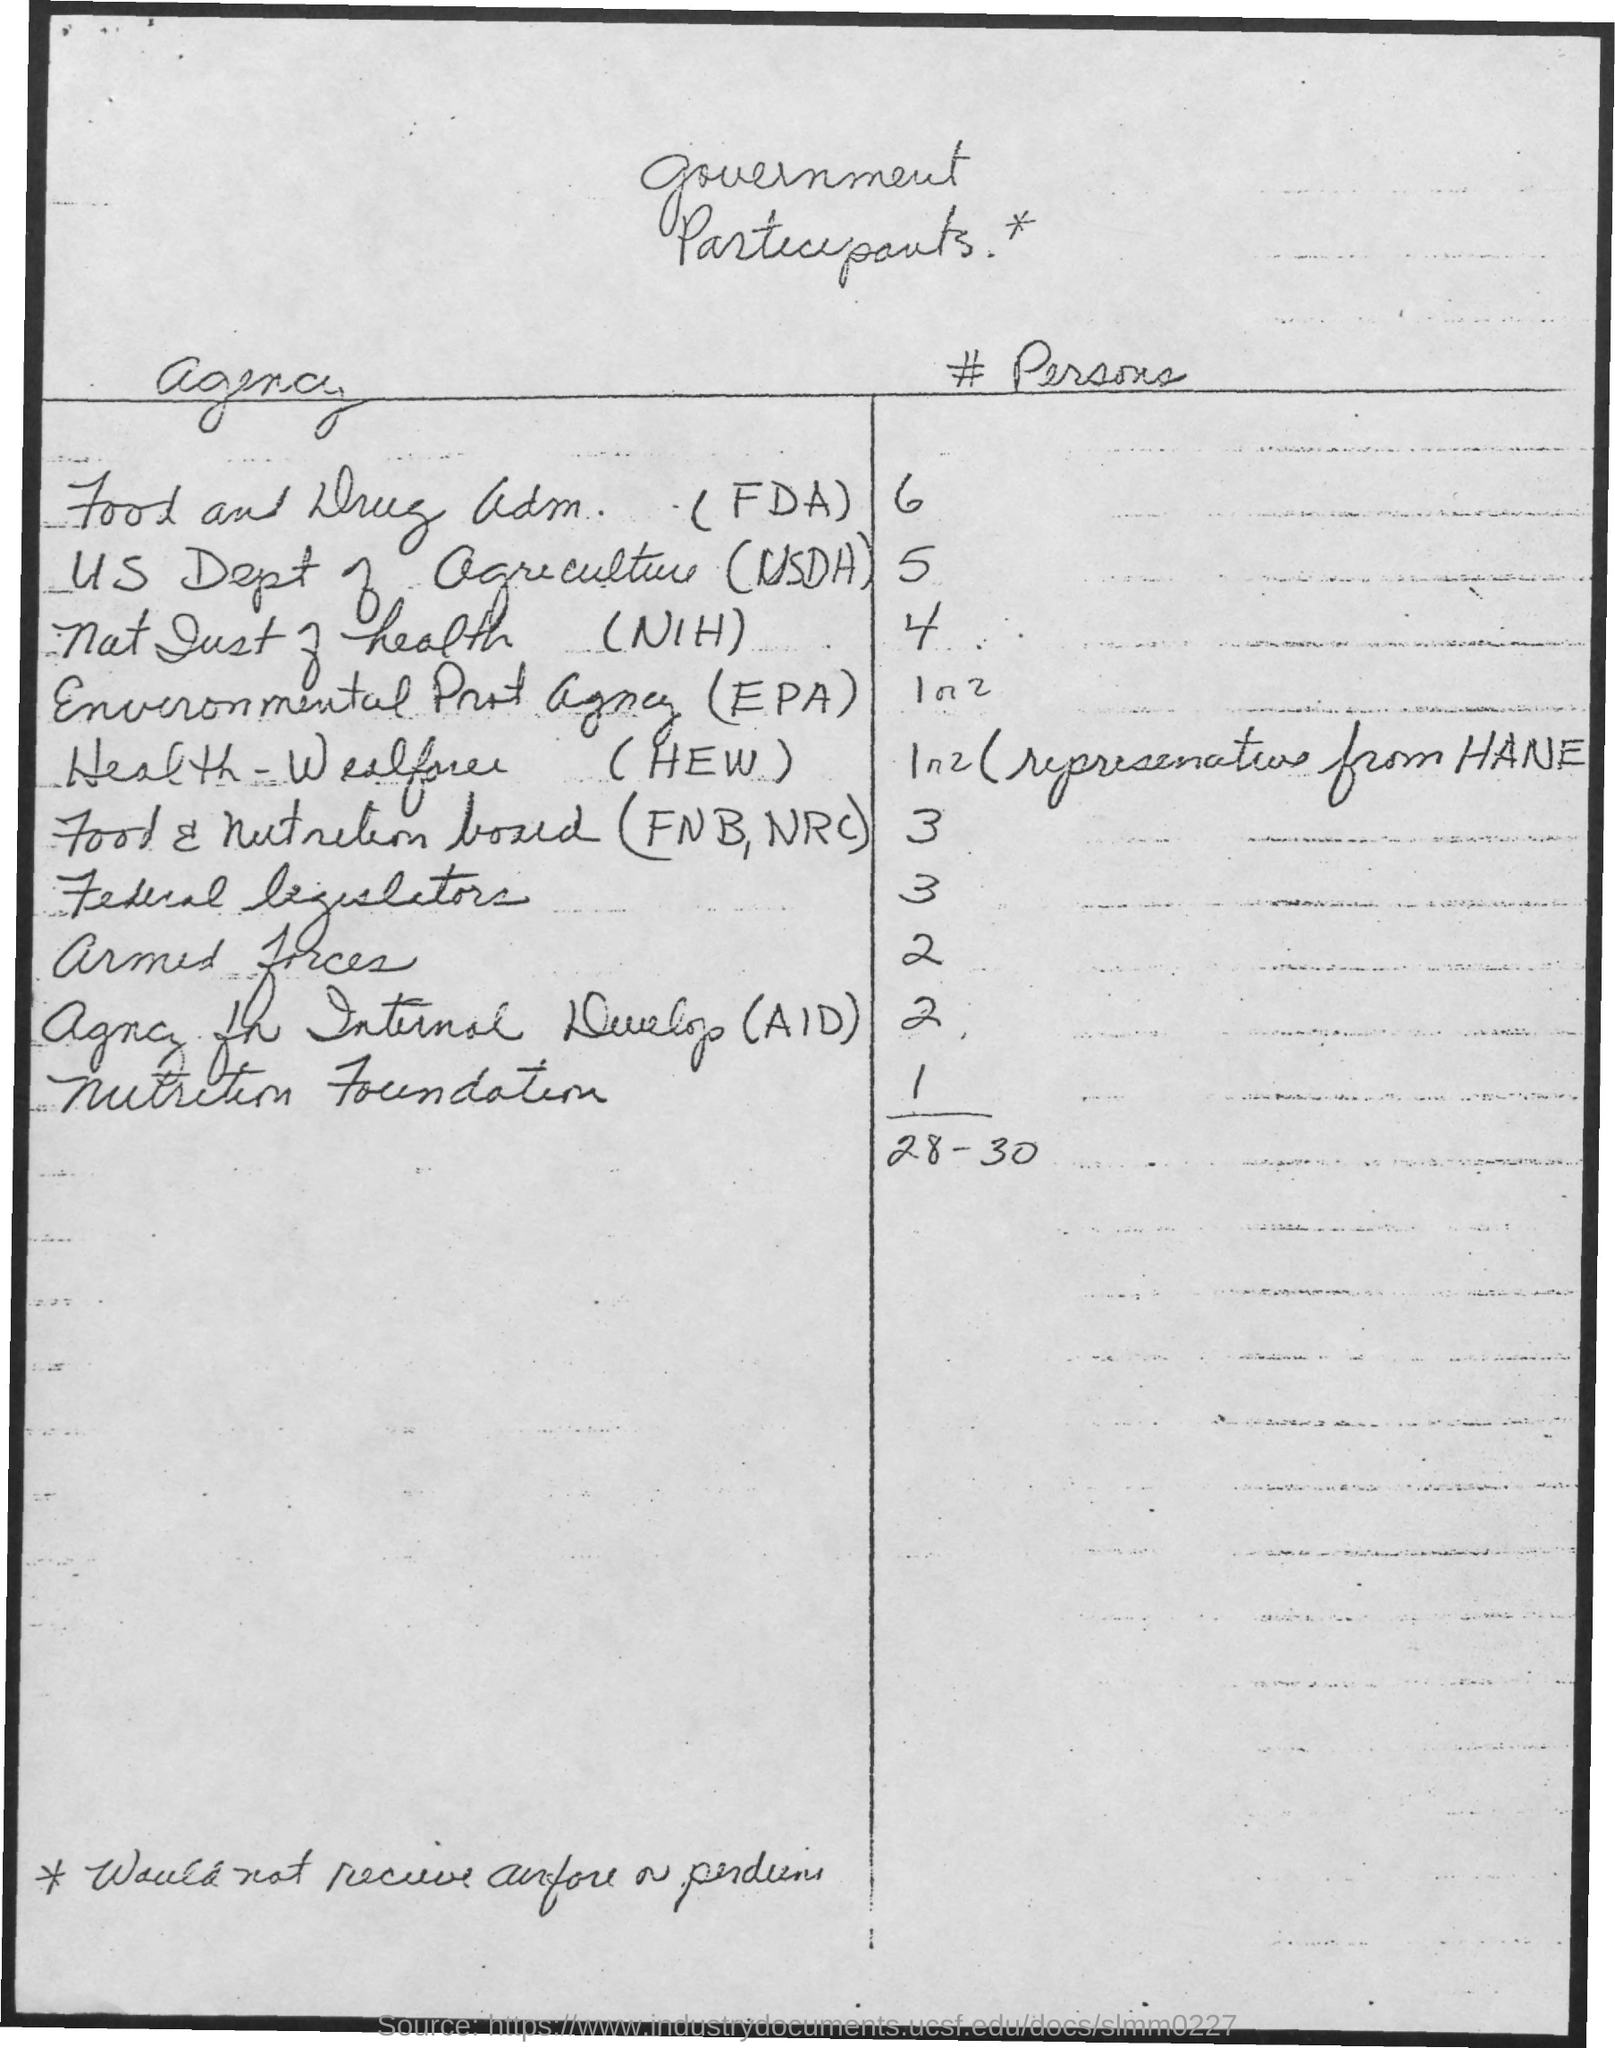Indicate a few pertinent items in this graphic. The number of participants from the armed forces is currently at 2. The heading of the table at the top of the page is "Government Participants. The heading for the first column of the table is labeled as 'Agency'. The number of participants from the Nutrition Foundation is between 1 and... The acronym "USDA" stands for the United States Department of Agriculture. 